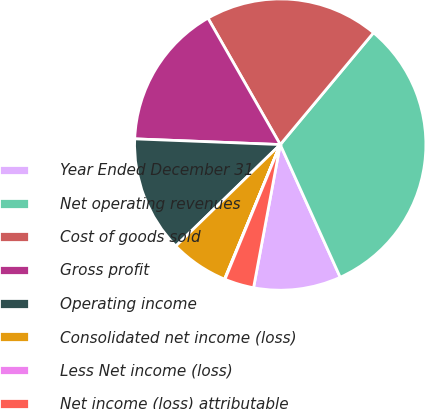Convert chart to OTSL. <chart><loc_0><loc_0><loc_500><loc_500><pie_chart><fcel>Year Ended December 31<fcel>Net operating revenues<fcel>Cost of goods sold<fcel>Gross profit<fcel>Operating income<fcel>Consolidated net income (loss)<fcel>Less Net income (loss)<fcel>Net income (loss) attributable<nl><fcel>9.69%<fcel>32.18%<fcel>19.33%<fcel>16.11%<fcel>12.9%<fcel>6.48%<fcel>0.05%<fcel>3.26%<nl></chart> 